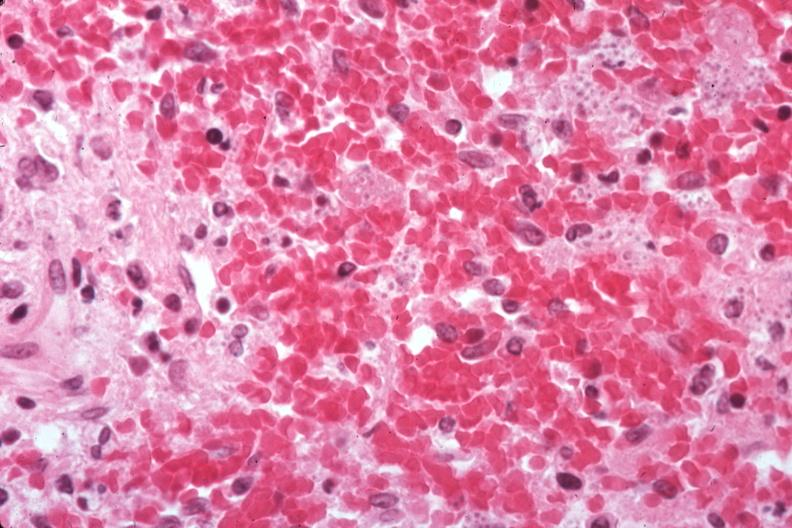does this image show organisms easily seen?
Answer the question using a single word or phrase. Yes 